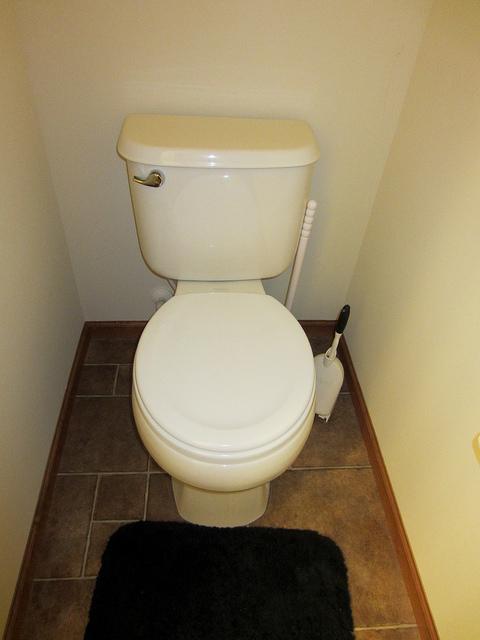Is there a toilet brush next to the toilet?
Write a very short answer. Yes. What is next to the toilet?
Concise answer only. Brush. What color is the tile behind the toilet?
Write a very short answer. Brown. Is there a plunger?
Quick response, please. Yes. What color is the rug?
Quick response, please. Black. What room is this?
Answer briefly. Bathroom. 